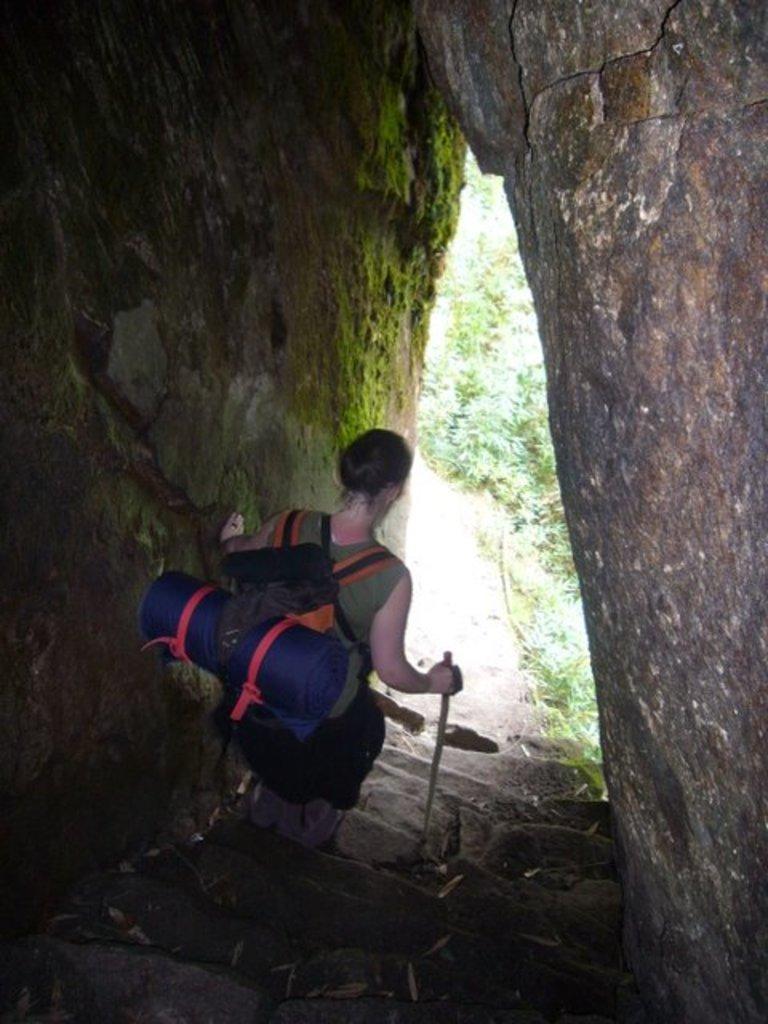Describe this image in one or two sentences. There is a woman holding a stick and carrying a bag. We can see algae, walls, steps and plants. 